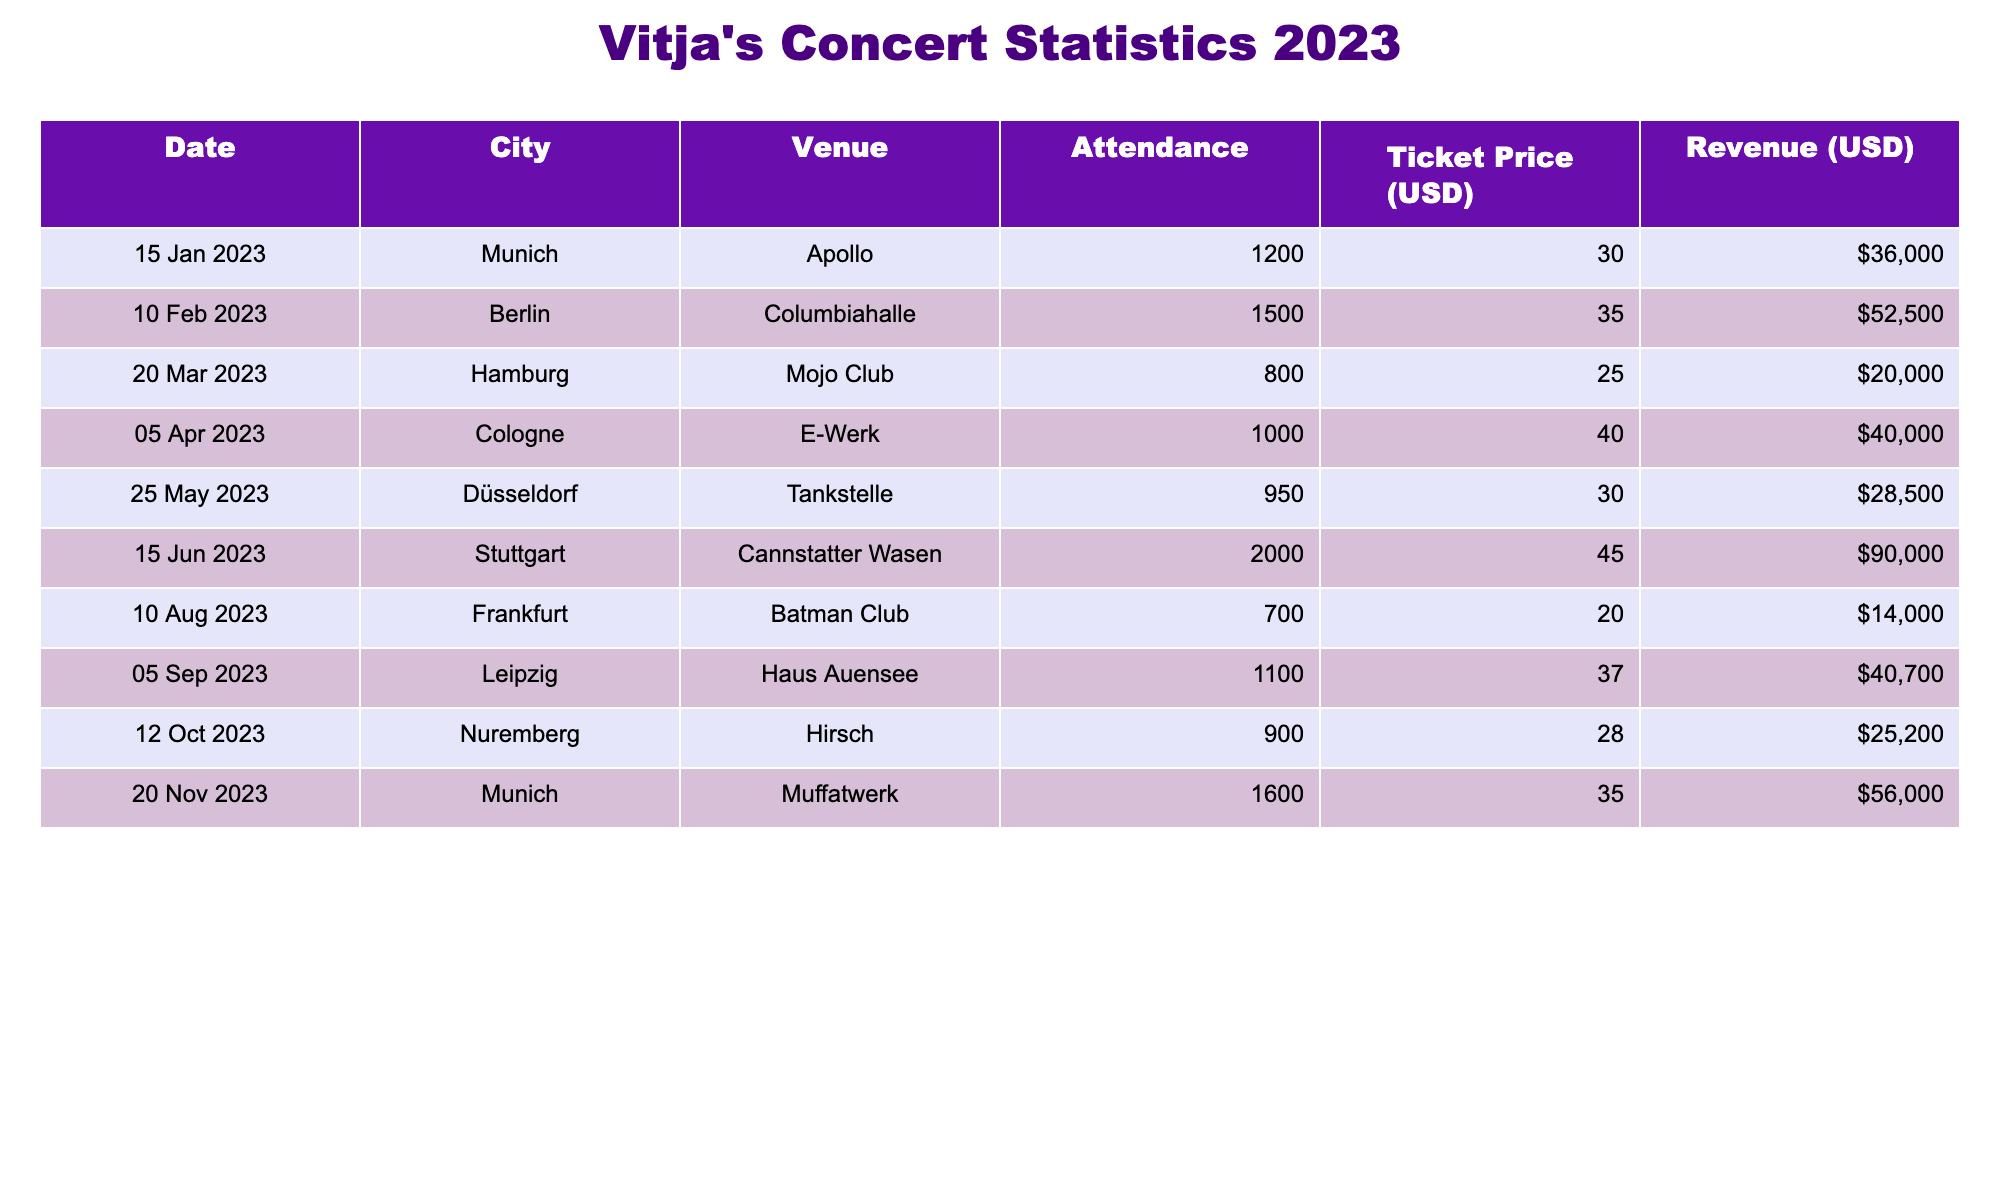What city had the highest concert attendance? By reviewing the attendance figures in the table, Stuttgart had the highest attendance at 2000.
Answer: Stuttgart What was the total revenue generated from concerts in Munich? The concerts in Munich occurred on January 15th with revenue of $36,000 and November 20th with revenue of $56,000. Therefore, total revenue is $36,000 + $56,000 = $92,000.
Answer: $92,000 Which concert had the lowest ticket price? The lowest ticket price was $20 for the Frankfurt concert on August 10th.
Answer: $20 Was the attendance in Cologne greater than in Hamburg? The attendance in Cologne was 1000 while in Hamburg it was 800. Since 1000 > 800, the statement is true.
Answer: Yes What is the average ticket price across all concerts? The ticket prices for the concerts are $30, $35, $25, $40, $30, $45, $20, $37, $28, and $35. Summing these gives $30 + $35 + $25 + $40 + $30 + $45 + $20 + $37 + $28 + $35 =  375. Dividing by the number of concerts (10), the average ticket price is $375 / 10 = $37.50.
Answer: $37.50 Which month had the least concert attendance overall? The monthly attendances are as follows: January (1200), February (1500), March (800), April (1000), May (950), June (2000), August (700), September (1100), October (900), and November (1600). The least attendance was in August with 700.
Answer: August Did Vitja perform at more indoor venues than outdoor ones? The venues listed include indoor ones like Columbiahalle, Mojo Club, E-Werk, Tankstelle, Cannstatter Wasen, Batman Club, Haus Auensee, and Muffatwerk. The only outdoor venue is Cannstatter Wasen. Since there are 8 indoor venues and only 1 outdoor, the answer is yes.
Answer: Yes How much more revenue was generated in Stuttgart than in Frankfurt? Revenue from Stuttgart was $90,000, and from Frankfurt was $14,000. Calculating the difference gives $90,000 - $14,000 = $76,000 more revenue in Stuttgart.
Answer: $76,000 